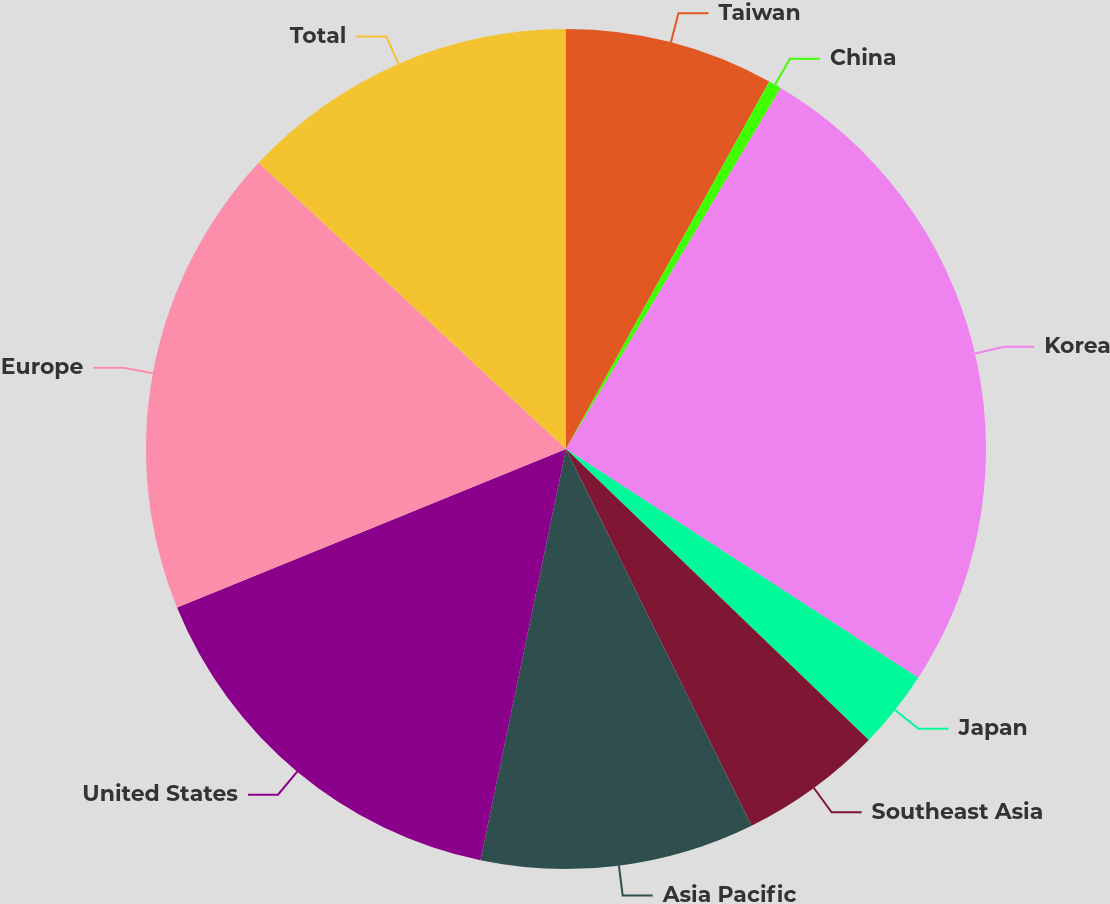Convert chart to OTSL. <chart><loc_0><loc_0><loc_500><loc_500><pie_chart><fcel>Taiwan<fcel>China<fcel>Korea<fcel>Japan<fcel>Southeast Asia<fcel>Asia Pacific<fcel>United States<fcel>Europe<fcel>Total<nl><fcel>8.04%<fcel>0.5%<fcel>25.63%<fcel>3.02%<fcel>5.53%<fcel>10.55%<fcel>15.58%<fcel>18.09%<fcel>13.07%<nl></chart> 